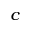<formula> <loc_0><loc_0><loc_500><loc_500>^ { c }</formula> 